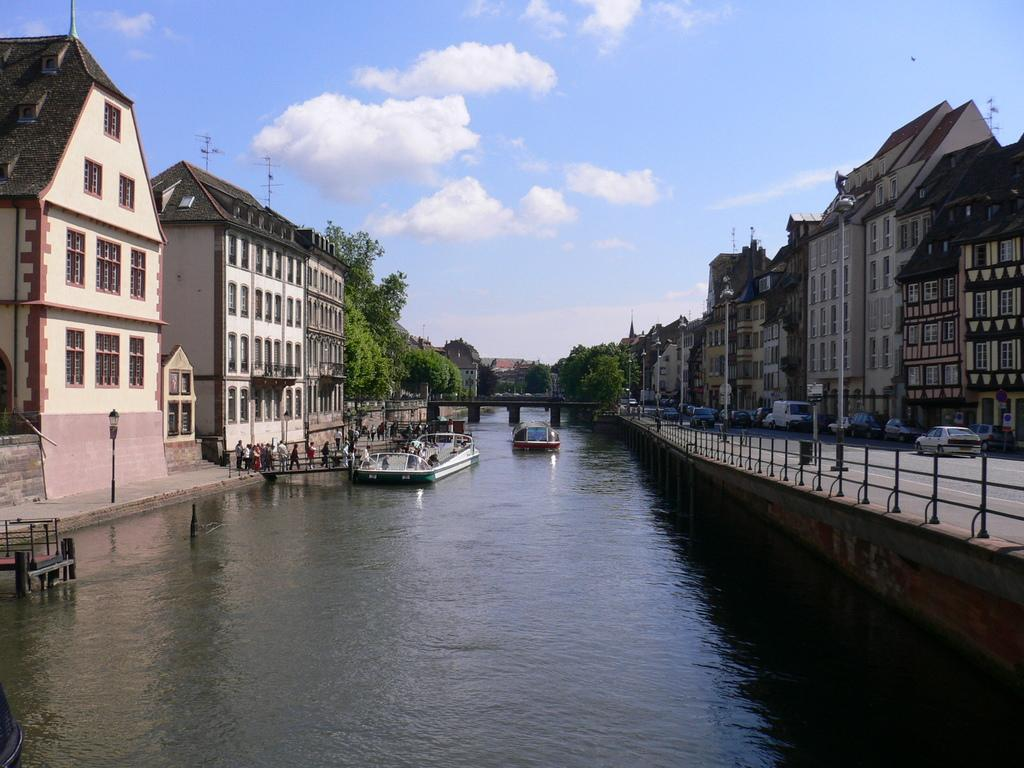What type of water feature is present in the image? There is a canal in the image. What surrounds the canal? The canal is situated between buildings and trees. What is floating on the water in the canal? There are boats floating on the water in the canal. What architectural feature can be seen in the middle of the image? There is a bridge in the middle of the image. What can be seen in the sky in the image? There are clouds visible in the sky. How many deer are present in the image? There are no deer present in the image. What type of medical professional can be seen treating patients in the image? There are no medical professionals present in the image. 